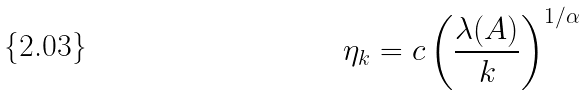Convert formula to latex. <formula><loc_0><loc_0><loc_500><loc_500>\eta _ { k } = c \left ( \frac { \lambda ( A ) } { k } \right ) ^ { 1 / \alpha }</formula> 